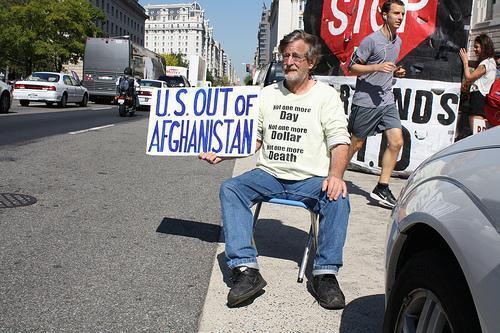How many people hold a sign?
Give a very brief answer. 1. How many people are sitting?
Give a very brief answer. 1. How many motorcycles are shown?
Give a very brief answer. 1. 